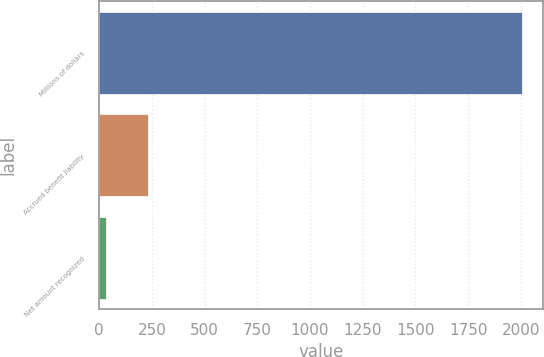<chart> <loc_0><loc_0><loc_500><loc_500><bar_chart><fcel>Millions of dollars<fcel>Accrued benefit liability<fcel>Net amount recognized<nl><fcel>2004<fcel>229.2<fcel>32<nl></chart> 